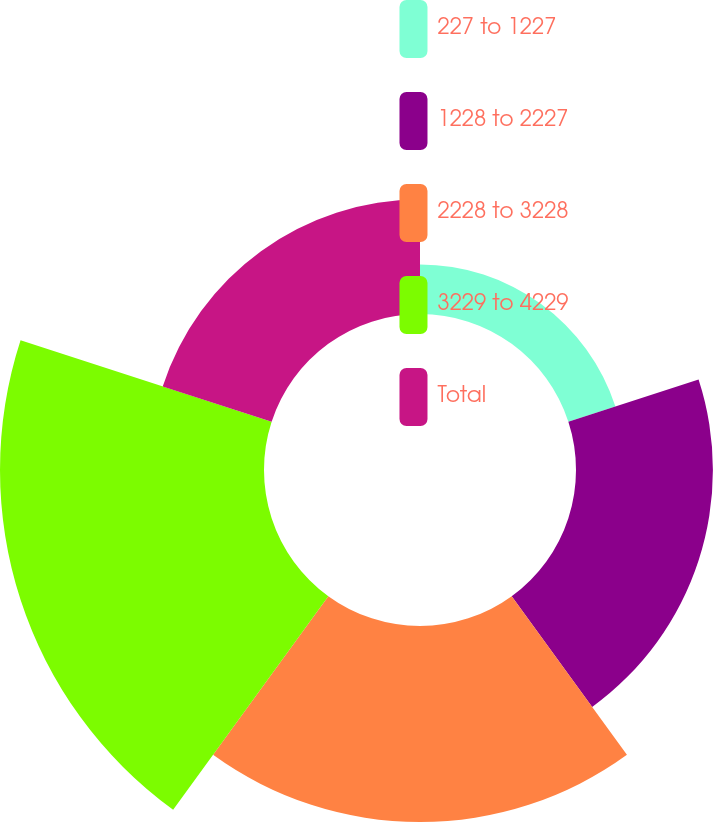<chart> <loc_0><loc_0><loc_500><loc_500><pie_chart><fcel>227 to 1227<fcel>1228 to 2227<fcel>2228 to 3228<fcel>3229 to 4229<fcel>Total<nl><fcel>6.5%<fcel>17.99%<fcel>25.76%<fcel>34.69%<fcel>15.05%<nl></chart> 